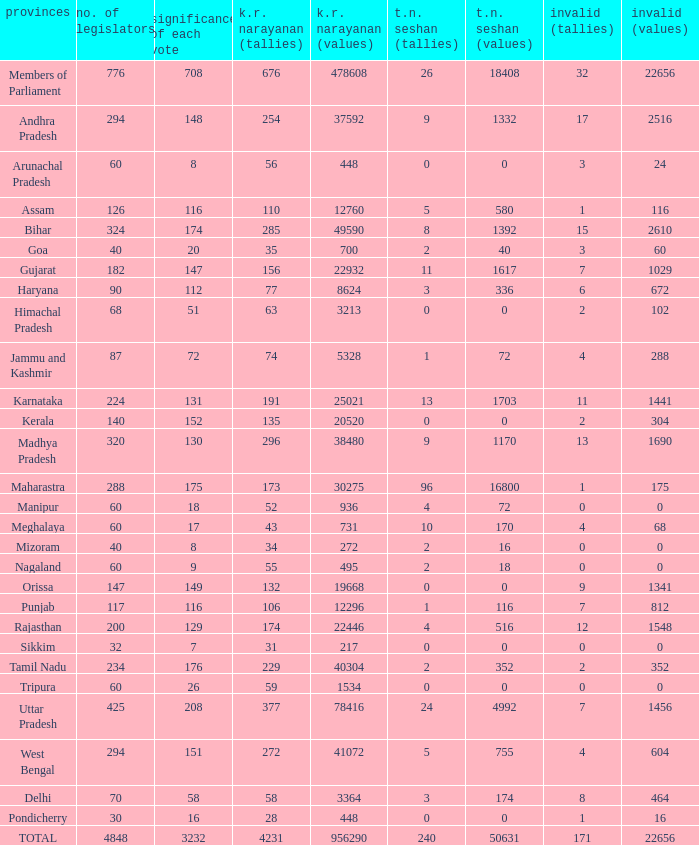Name the kr narayanan votes for values being 936 for kr 52.0. 